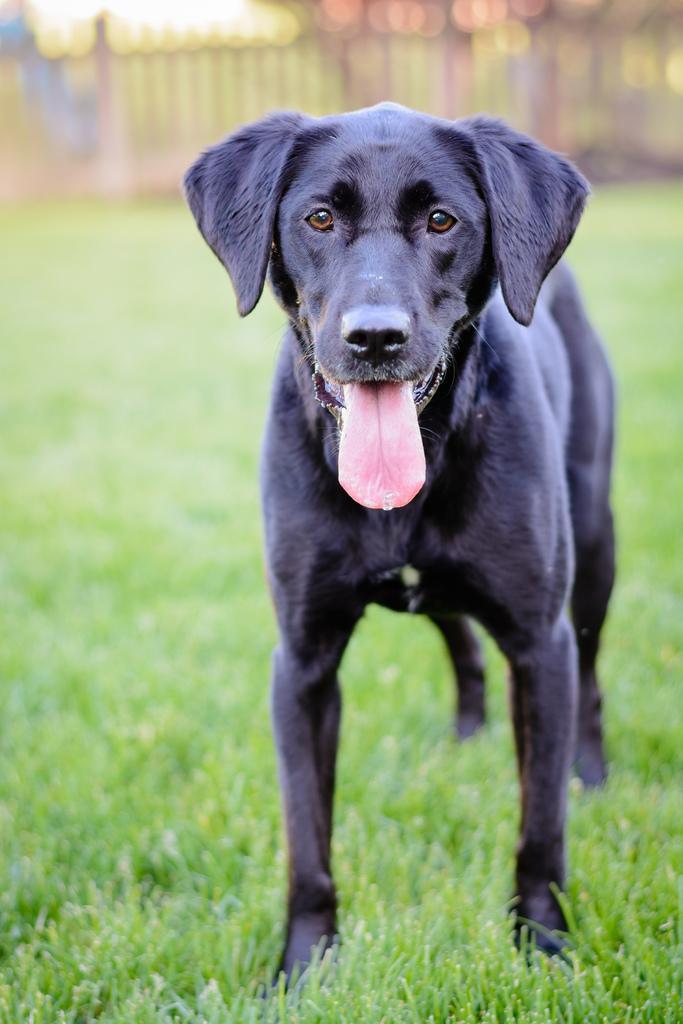How would you summarize this image in a sentence or two? In this picture we can see dog standing on the grass. 